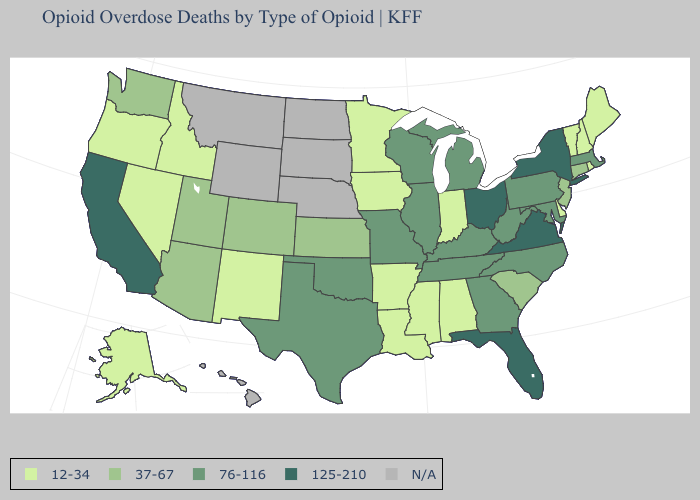What is the lowest value in states that border Pennsylvania?
Quick response, please. 12-34. Among the states that border Florida , does Alabama have the highest value?
Answer briefly. No. What is the lowest value in the USA?
Be succinct. 12-34. Name the states that have a value in the range 76-116?
Short answer required. Georgia, Illinois, Kentucky, Maryland, Massachusetts, Michigan, Missouri, North Carolina, Oklahoma, Pennsylvania, Tennessee, Texas, West Virginia, Wisconsin. Name the states that have a value in the range 37-67?
Answer briefly. Arizona, Colorado, Connecticut, Kansas, New Jersey, South Carolina, Utah, Washington. What is the value of Utah?
Short answer required. 37-67. What is the lowest value in states that border Louisiana?
Short answer required. 12-34. What is the highest value in states that border Colorado?
Give a very brief answer. 76-116. Is the legend a continuous bar?
Short answer required. No. What is the lowest value in the USA?
Write a very short answer. 12-34. Does Alabama have the lowest value in the South?
Give a very brief answer. Yes. How many symbols are there in the legend?
Write a very short answer. 5. Name the states that have a value in the range 37-67?
Short answer required. Arizona, Colorado, Connecticut, Kansas, New Jersey, South Carolina, Utah, Washington. 